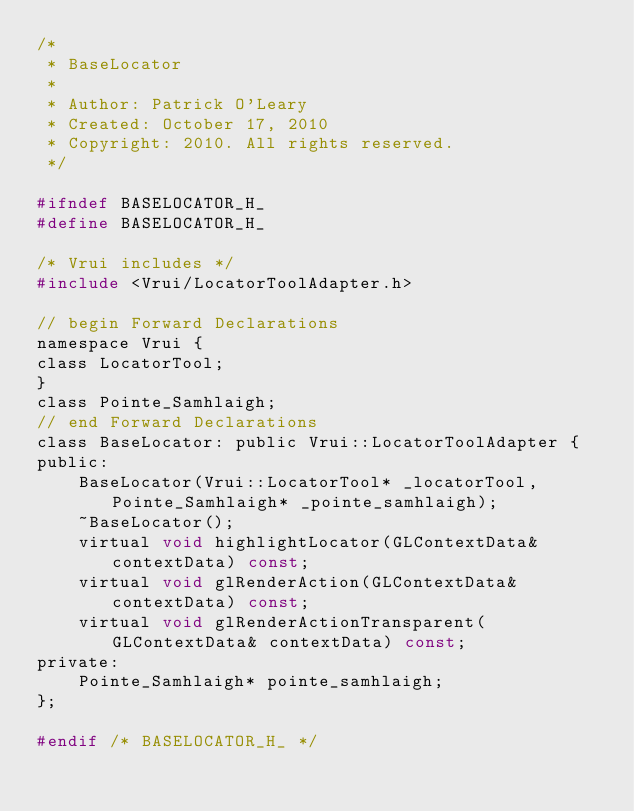Convert code to text. <code><loc_0><loc_0><loc_500><loc_500><_C_>/*
 * BaseLocator
 *
 * Author: Patrick O'Leary
 * Created: October 17, 2010
 * Copyright: 2010. All rights reserved.
 */

#ifndef BASELOCATOR_H_
#define BASELOCATOR_H_

/* Vrui includes */
#include <Vrui/LocatorToolAdapter.h>

// begin Forward Declarations
namespace Vrui {
class LocatorTool;
}
class Pointe_Samhlaigh;
// end Forward Declarations
class BaseLocator: public Vrui::LocatorToolAdapter {
public:
    BaseLocator(Vrui::LocatorTool* _locatorTool, Pointe_Samhlaigh* _pointe_samhlaigh);
    ~BaseLocator();
    virtual void highlightLocator(GLContextData& contextData) const;
    virtual void glRenderAction(GLContextData& contextData) const;
    virtual void glRenderActionTransparent(GLContextData& contextData) const;
private:
    Pointe_Samhlaigh* pointe_samhlaigh;
};

#endif /* BASELOCATOR_H_ */
</code> 